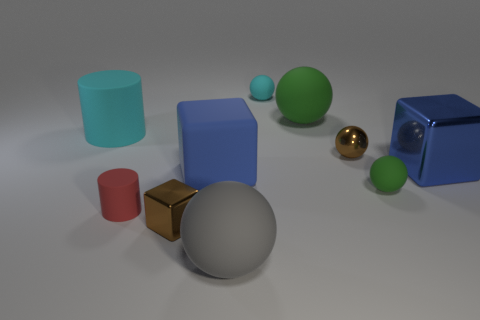There is a blue object that is right of the tiny cyan sphere; how big is it?
Provide a short and direct response. Large. How many green objects are either small metal objects or small balls?
Provide a short and direct response. 1. Are there any other matte cubes of the same size as the rubber cube?
Your answer should be very brief. No. There is a blue thing that is the same size as the matte cube; what material is it?
Offer a very short reply. Metal. Is the size of the cylinder that is in front of the big cyan rubber cylinder the same as the green rubber sphere behind the tiny brown sphere?
Provide a short and direct response. No. How many objects are either cyan blocks or small spheres in front of the big cyan thing?
Ensure brevity in your answer.  2. Are there any big gray rubber things of the same shape as the red thing?
Keep it short and to the point. No. What is the size of the green matte sphere behind the cube to the right of the brown sphere?
Make the answer very short. Large. Is the tiny rubber cylinder the same color as the tiny metallic cube?
Your answer should be compact. No. How many metallic things are objects or small objects?
Your answer should be compact. 3. 